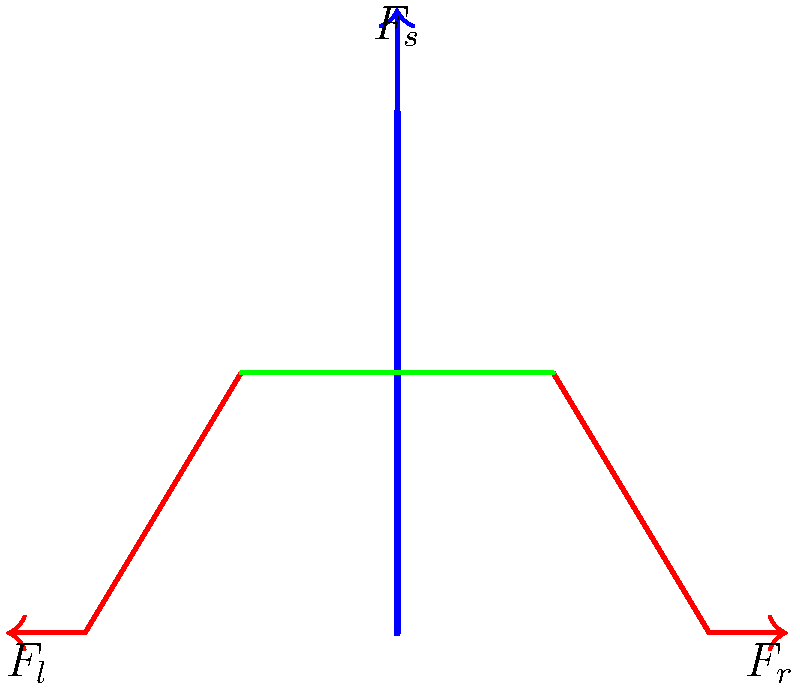In a proper deadlift technique, the spine should remain neutral to evenly distribute forces. Using the simplified skeletal diagram, if the total force exerted by the legs ($F_l$ and $F_r$ combined) is 1000N, and the spine experiences a compressive force ($F_s$) of 800N, what is the approximate angle (in degrees) between the spine and the vertical axis to maintain equilibrium? To solve this problem, we'll use the principles of force equilibrium:

1. In equilibrium, the sum of all forces must be zero.
2. We can break down the forces into vertical and horizontal components.
3. The vertical components of the leg forces must balance the spine force.
4. The horizontal components of the leg forces must balance each other.

Let's proceed step-by-step:

1. Let θ be the angle between the spine and the vertical axis.
2. The total leg force is 1000N, so each leg contributes 500N (assuming symmetry).
3. The vertical component of each leg force is: $500 \cos θ$
4. The total vertical component from both legs is: $1000 \cos θ$
5. This must equal the spine force for vertical equilibrium: $1000 \cos θ = 800$
6. Solving for θ: $\cos θ = \frac{800}{1000} = 0.8$
7. Taking the inverse cosine (arccos): $θ = \arccos(0.8)$
8. Converting to degrees: $θ ≈ 36.87°$

Therefore, the angle between the spine and the vertical axis should be approximately 37 degrees to maintain equilibrium under the given forces.
Answer: 37° 